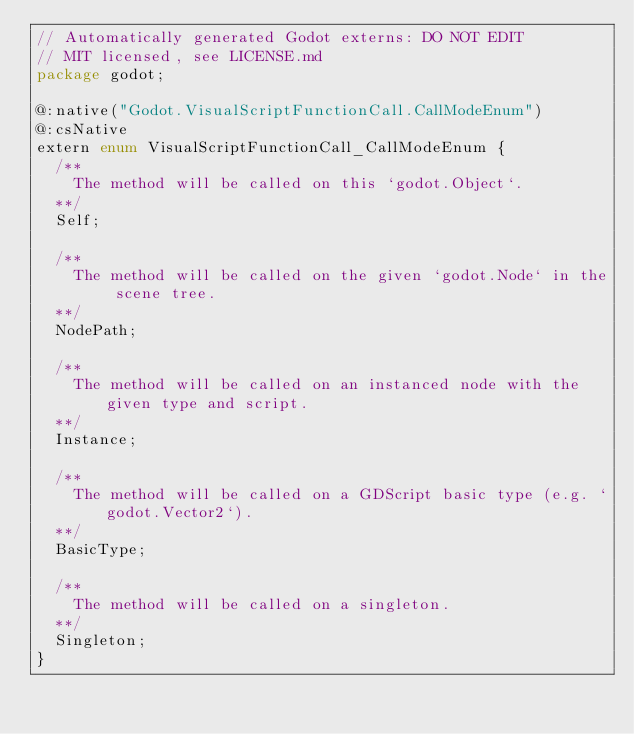<code> <loc_0><loc_0><loc_500><loc_500><_Haxe_>// Automatically generated Godot externs: DO NOT EDIT
// MIT licensed, see LICENSE.md
package godot;

@:native("Godot.VisualScriptFunctionCall.CallModeEnum")
@:csNative
extern enum VisualScriptFunctionCall_CallModeEnum {
	/**		
		The method will be called on this `godot.Object`.
	**/
	Self;

	/**		
		The method will be called on the given `godot.Node` in the scene tree.
	**/
	NodePath;

	/**		
		The method will be called on an instanced node with the given type and script.
	**/
	Instance;

	/**		
		The method will be called on a GDScript basic type (e.g. `godot.Vector2`).
	**/
	BasicType;

	/**		
		The method will be called on a singleton.
	**/
	Singleton;
}
</code> 